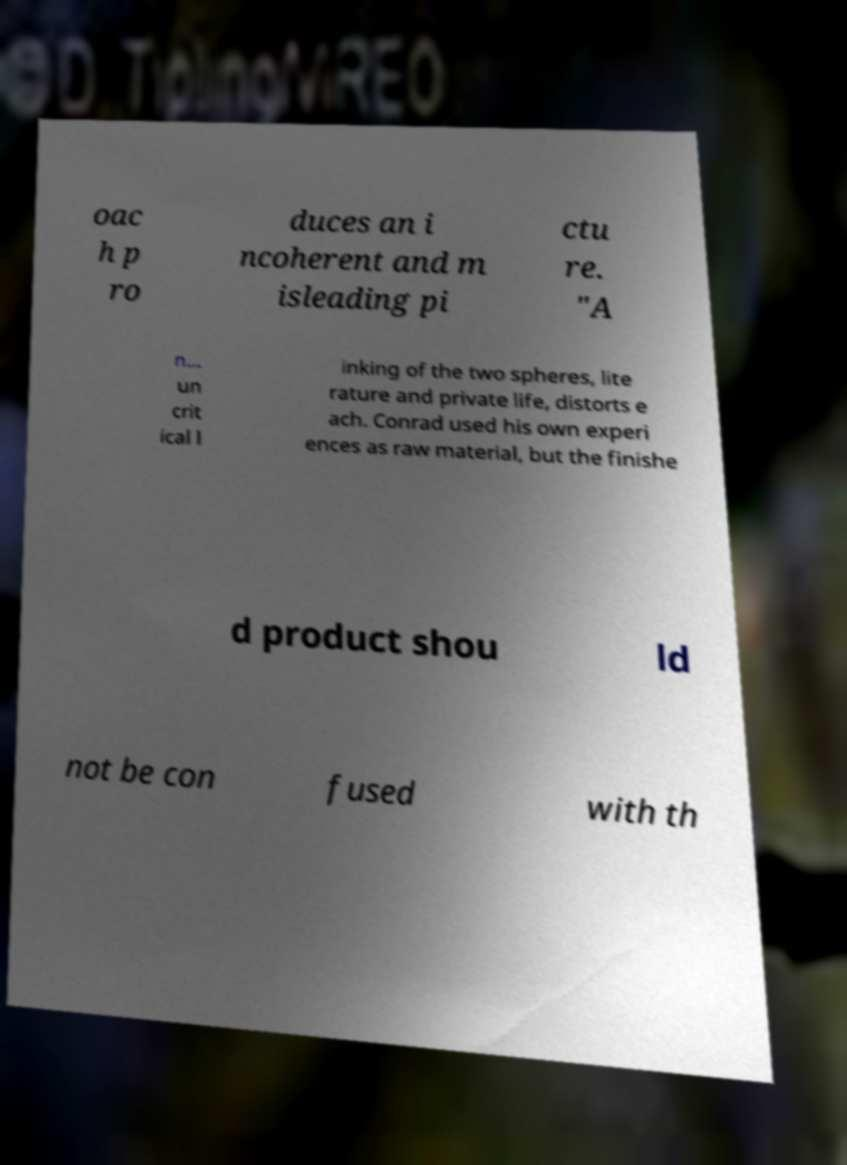Please read and relay the text visible in this image. What does it say? oac h p ro duces an i ncoherent and m isleading pi ctu re. "A n... un crit ical l inking of the two spheres, lite rature and private life, distorts e ach. Conrad used his own experi ences as raw material, but the finishe d product shou ld not be con fused with th 